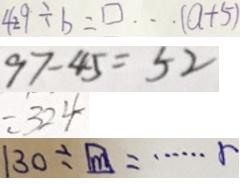Convert formula to latex. <formula><loc_0><loc_0><loc_500><loc_500>4 2 9 \div b = \square \cdots ( a + 5 ) 
 9 7 - 4 5 = 5 2 
 = 3 2 4 
 1 3 0 \div \boxed { m } = \cdots r</formula> 